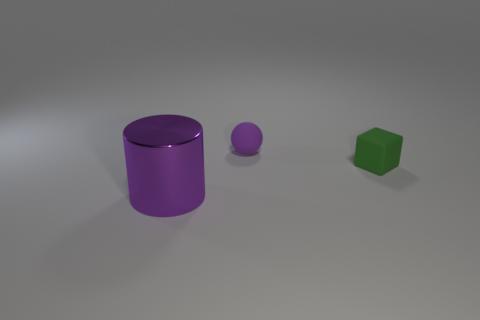Can you guess the material of these objects? Based on the smoothness and reflective quality of the objects, they seem to be made of a plastic or metallic material with a matte finish. 